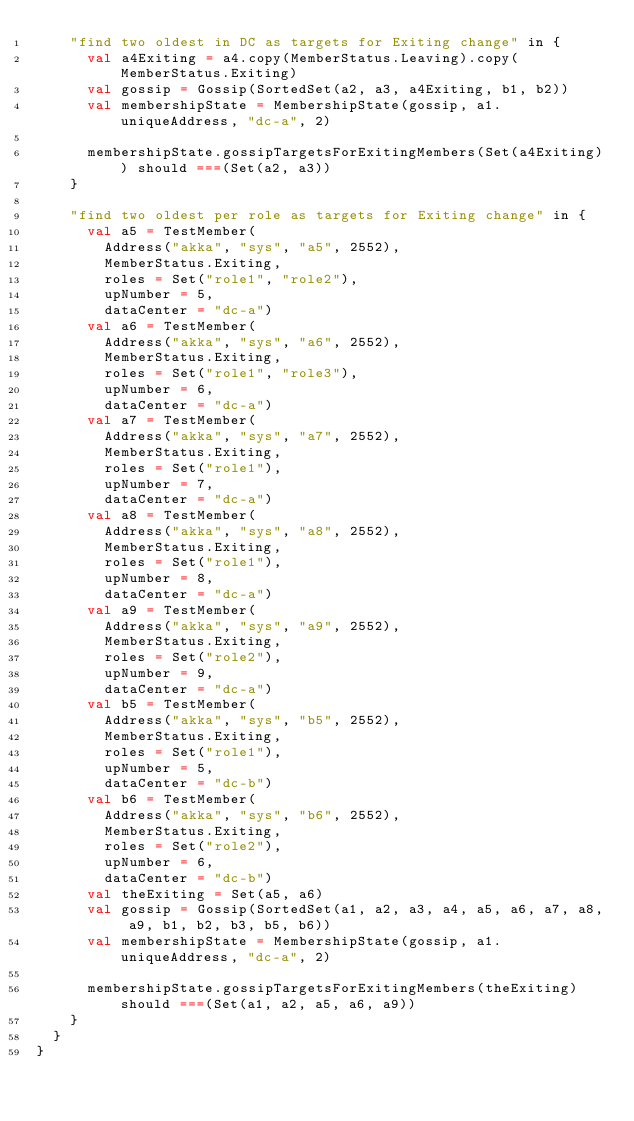<code> <loc_0><loc_0><loc_500><loc_500><_Scala_>    "find two oldest in DC as targets for Exiting change" in {
      val a4Exiting = a4.copy(MemberStatus.Leaving).copy(MemberStatus.Exiting)
      val gossip = Gossip(SortedSet(a2, a3, a4Exiting, b1, b2))
      val membershipState = MembershipState(gossip, a1.uniqueAddress, "dc-a", 2)

      membershipState.gossipTargetsForExitingMembers(Set(a4Exiting)) should ===(Set(a2, a3))
    }

    "find two oldest per role as targets for Exiting change" in {
      val a5 = TestMember(
        Address("akka", "sys", "a5", 2552),
        MemberStatus.Exiting,
        roles = Set("role1", "role2"),
        upNumber = 5,
        dataCenter = "dc-a")
      val a6 = TestMember(
        Address("akka", "sys", "a6", 2552),
        MemberStatus.Exiting,
        roles = Set("role1", "role3"),
        upNumber = 6,
        dataCenter = "dc-a")
      val a7 = TestMember(
        Address("akka", "sys", "a7", 2552),
        MemberStatus.Exiting,
        roles = Set("role1"),
        upNumber = 7,
        dataCenter = "dc-a")
      val a8 = TestMember(
        Address("akka", "sys", "a8", 2552),
        MemberStatus.Exiting,
        roles = Set("role1"),
        upNumber = 8,
        dataCenter = "dc-a")
      val a9 = TestMember(
        Address("akka", "sys", "a9", 2552),
        MemberStatus.Exiting,
        roles = Set("role2"),
        upNumber = 9,
        dataCenter = "dc-a")
      val b5 = TestMember(
        Address("akka", "sys", "b5", 2552),
        MemberStatus.Exiting,
        roles = Set("role1"),
        upNumber = 5,
        dataCenter = "dc-b")
      val b6 = TestMember(
        Address("akka", "sys", "b6", 2552),
        MemberStatus.Exiting,
        roles = Set("role2"),
        upNumber = 6,
        dataCenter = "dc-b")
      val theExiting = Set(a5, a6)
      val gossip = Gossip(SortedSet(a1, a2, a3, a4, a5, a6, a7, a8, a9, b1, b2, b3, b5, b6))
      val membershipState = MembershipState(gossip, a1.uniqueAddress, "dc-a", 2)

      membershipState.gossipTargetsForExitingMembers(theExiting) should ===(Set(a1, a2, a5, a6, a9))
    }
  }
}
</code> 